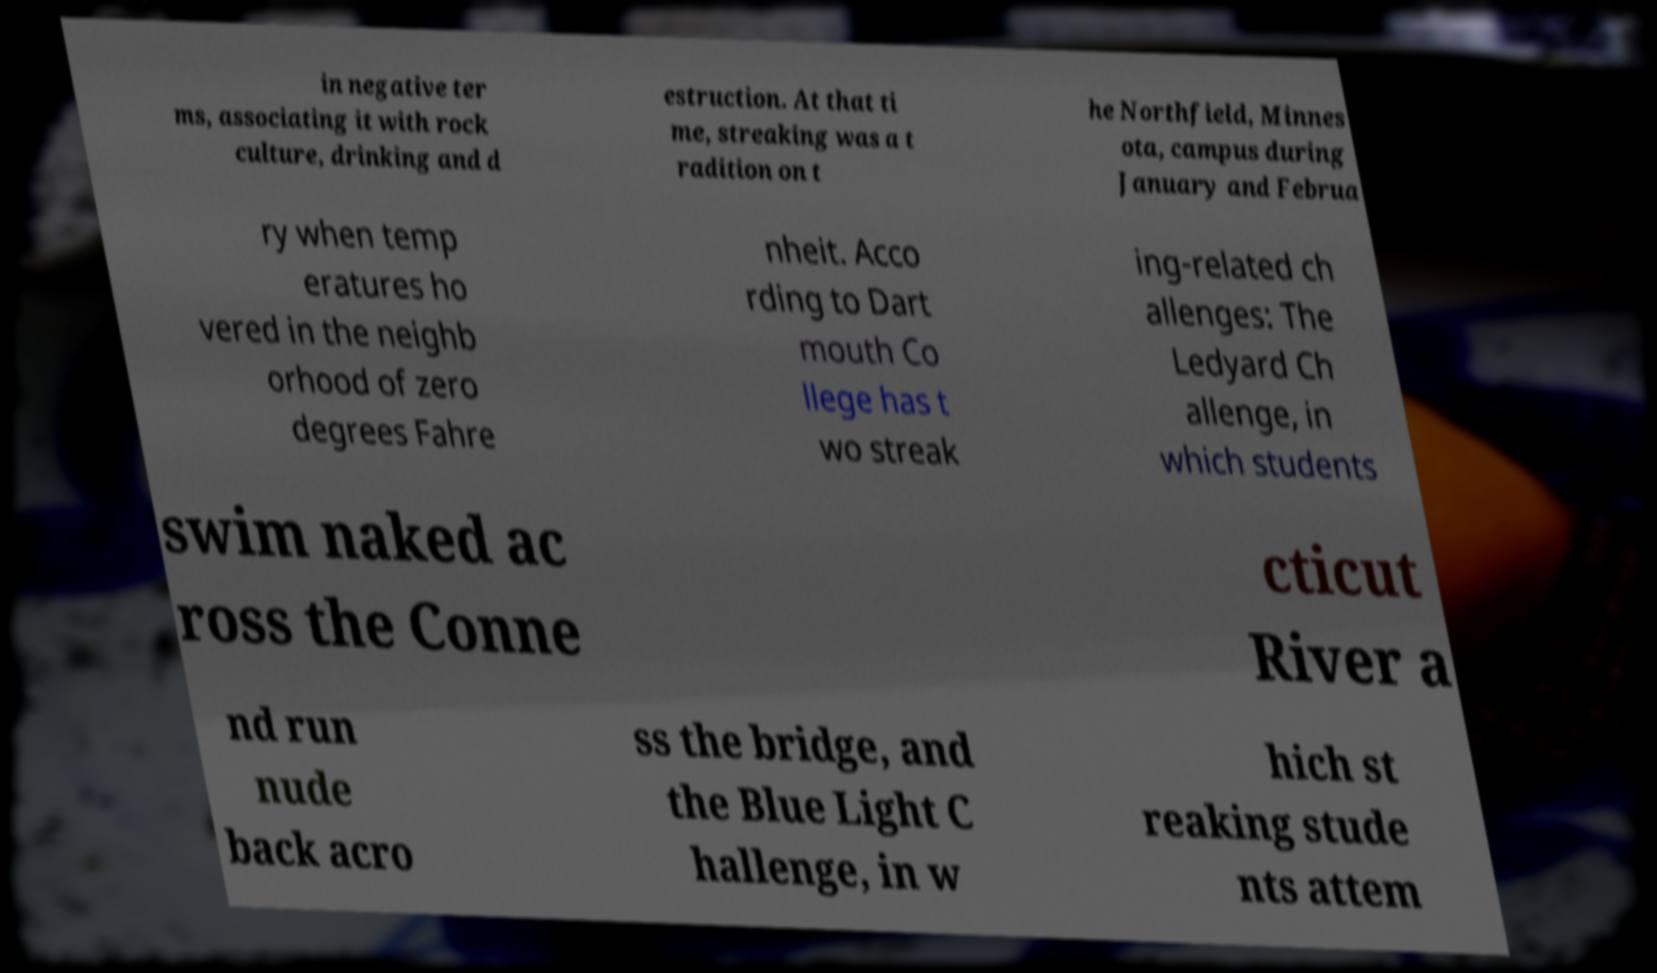Could you extract and type out the text from this image? in negative ter ms, associating it with rock culture, drinking and d estruction. At that ti me, streaking was a t radition on t he Northfield, Minnes ota, campus during January and Februa ry when temp eratures ho vered in the neighb orhood of zero degrees Fahre nheit. Acco rding to Dart mouth Co llege has t wo streak ing-related ch allenges: The Ledyard Ch allenge, in which students swim naked ac ross the Conne cticut River a nd run nude back acro ss the bridge, and the Blue Light C hallenge, in w hich st reaking stude nts attem 